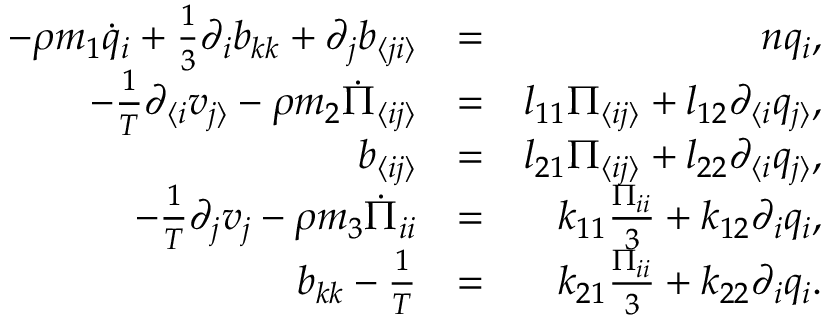<formula> <loc_0><loc_0><loc_500><loc_500>\begin{array} { r l r } { - \rho m _ { 1 } \dot { q } _ { i } + \frac { 1 } { 3 } \partial _ { i } b _ { k k } + \partial _ { j } b _ { \langle j i \rangle } } & { = } & { n q _ { i } , } \\ { - \frac { 1 } { T } \partial _ { \langle i } v _ { j \rangle } - \rho m _ { 2 } \dot { \Pi } _ { \langle i j \rangle } } & { = } & { l _ { 1 1 } \Pi _ { \langle i j \rangle } + l _ { 1 2 } \partial _ { \langle i } q _ { j \rangle } , } \\ { b _ { \langle i j \rangle } } & { = } & { l _ { 2 1 } \Pi _ { \langle i j \rangle } + l _ { 2 2 } \partial _ { \langle i } q _ { j \rangle } , } \\ { - \frac { 1 } { T } \partial _ { j } v _ { j } - \rho m _ { 3 } \dot { \Pi } _ { i i } } & { = } & { k _ { 1 1 } \frac { \Pi _ { i i } } { 3 } + k _ { 1 2 } \partial _ { i } q _ { i } , } \\ { b _ { k k } - \frac { 1 } { T } } & { = } & { k _ { 2 1 } \frac { \Pi _ { i i } } { 3 } + k _ { 2 2 } \partial _ { i } q _ { i } . } \end{array}</formula> 